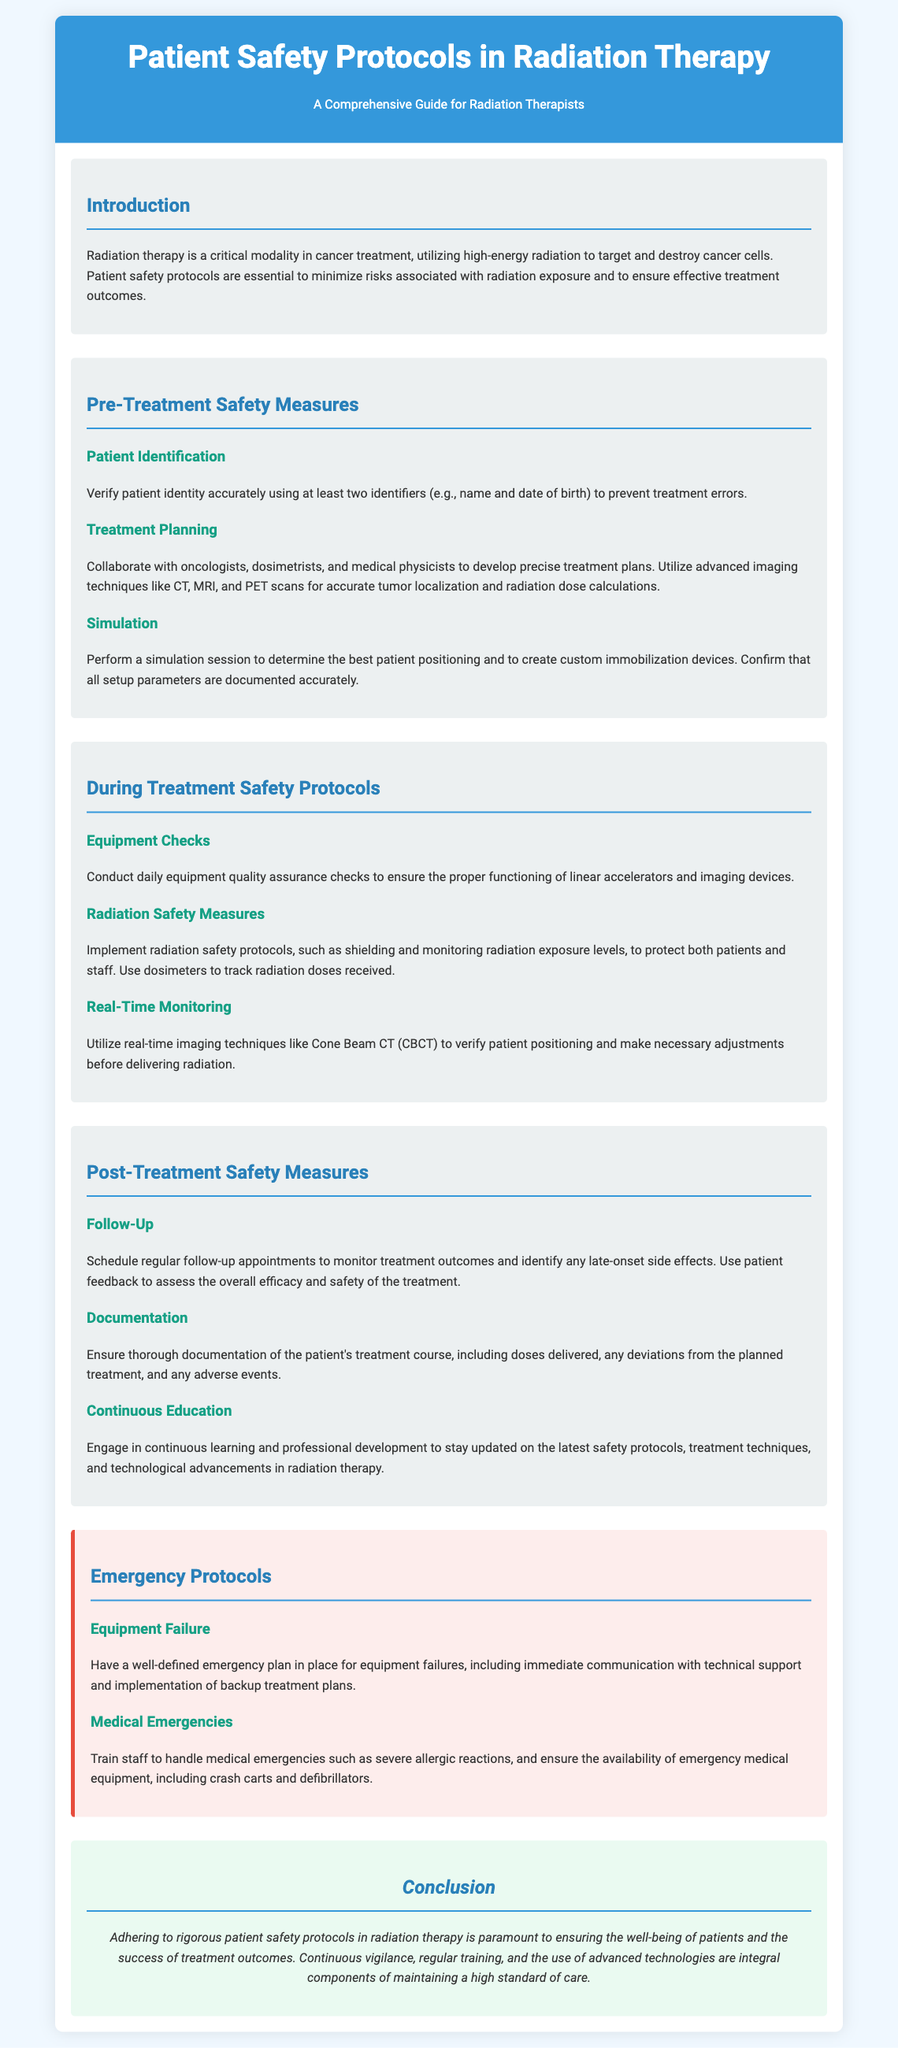What is the main purpose of the document? The main purpose of the document is to provide a comprehensive guide on patient safety protocols in radiation therapy.
Answer: Comprehensive guide on patient safety protocols in radiation therapy How many sections are there in the document? The document is divided into five main sections: Introduction, Pre-Treatment Safety Measures, During Treatment Safety Protocols, Post-Treatment Safety Measures, and Emergency Protocols.
Answer: Five What is one method used for patient identification? The document states that patient identity should be verified using at least two identifiers, such as name and date of birth.
Answer: Name and date of birth What should be documented during simulations? All setup parameters are to be documented accurately during the simulation session.
Answer: Setup parameters What equipment checks are recommended during treatment? Daily equipment quality assurance checks are recommended to ensure the proper functioning of linear accelerators and imaging devices.
Answer: Daily equipment quality assurance checks Name one follow-up measure after treatment. Regular follow-up appointments should be scheduled to monitor treatment outcomes and identify any late-onset side effects.
Answer: Regular follow-up appointments What type of emergencies does the document mention? The document mentions equipment failures and medical emergencies requiring a trained response.
Answer: Equipment failures and medical emergencies What is emphasized as essential for the success of treatment outcomes? Adhering to rigorous patient safety protocols is emphasized as essential for treatment success.
Answer: Rigorous patient safety protocols 